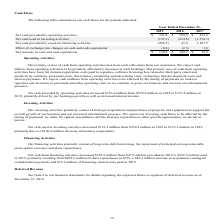From Godaddy's financial document, What are the 3 types of activities that cash flow comprises of? The document contains multiple relevant values: Operating, Investing, Financing. From the document: "tivities $ 723.4 $ 559.8 $ 475.6 Net cash used in investing activities (135.3) (254.8) (1,570.1) Net cash provided by (used in) financing activities (..." Also, What is the net cash provided by operating activities for year ended 2019? According to the financial document, $723.4 (in millions). The relevant text states: "2017 Net cash provided by operating activities $ 723.4 $ 559.8 $ 475.6 Net cash used in investing activities (135.3) (254.8) (1,570.1) Net cash provided b..." Also, What is the net cash provided by operating activities for year ended 2018? According to the financial document, $559.8 (in millions). The relevant text states: "t cash provided by operating activities $ 723.4 $ 559.8 $ 475.6 Net cash used in investing activities (135.3) (254.8) (1,570.1) Net cash provided by (used..." Also, can you calculate: What is the average net cash provided by operating activities for 2018 and 2019? To answer this question, I need to perform calculations using the financial data. The calculation is: (723.4+559.8)/2, which equals 641.6 (in millions). This is based on the information: "t cash provided by operating activities $ 723.4 $ 559.8 $ 475.6 Net cash used in investing activities (135.3) (254.8) (1,570.1) Net cash provided by (used 2017 Net cash provided by operating activitie..." The key data points involved are: 559.8, 723.4. Additionally, Between 2018 and 2019, which year has the highest Net increase in cash and cash equivalents? According to the financial document, 2018. The relevant text states: "Year Ended December 31, 2019 2018 2017 Net cash provided by operating activities $ 723.4 $ 559.8 $ 475.6 Net cash used in investing a..." Additionally, Which year has the highest Net cash provided by operating activities? According to the financial document, 2019. The relevant text states: "Year Ended December 31, 2019 2018 2017 Net cash provided by operating activities $ 723.4 $ 559.8 $ 475.6 Net cash used in invest..." 